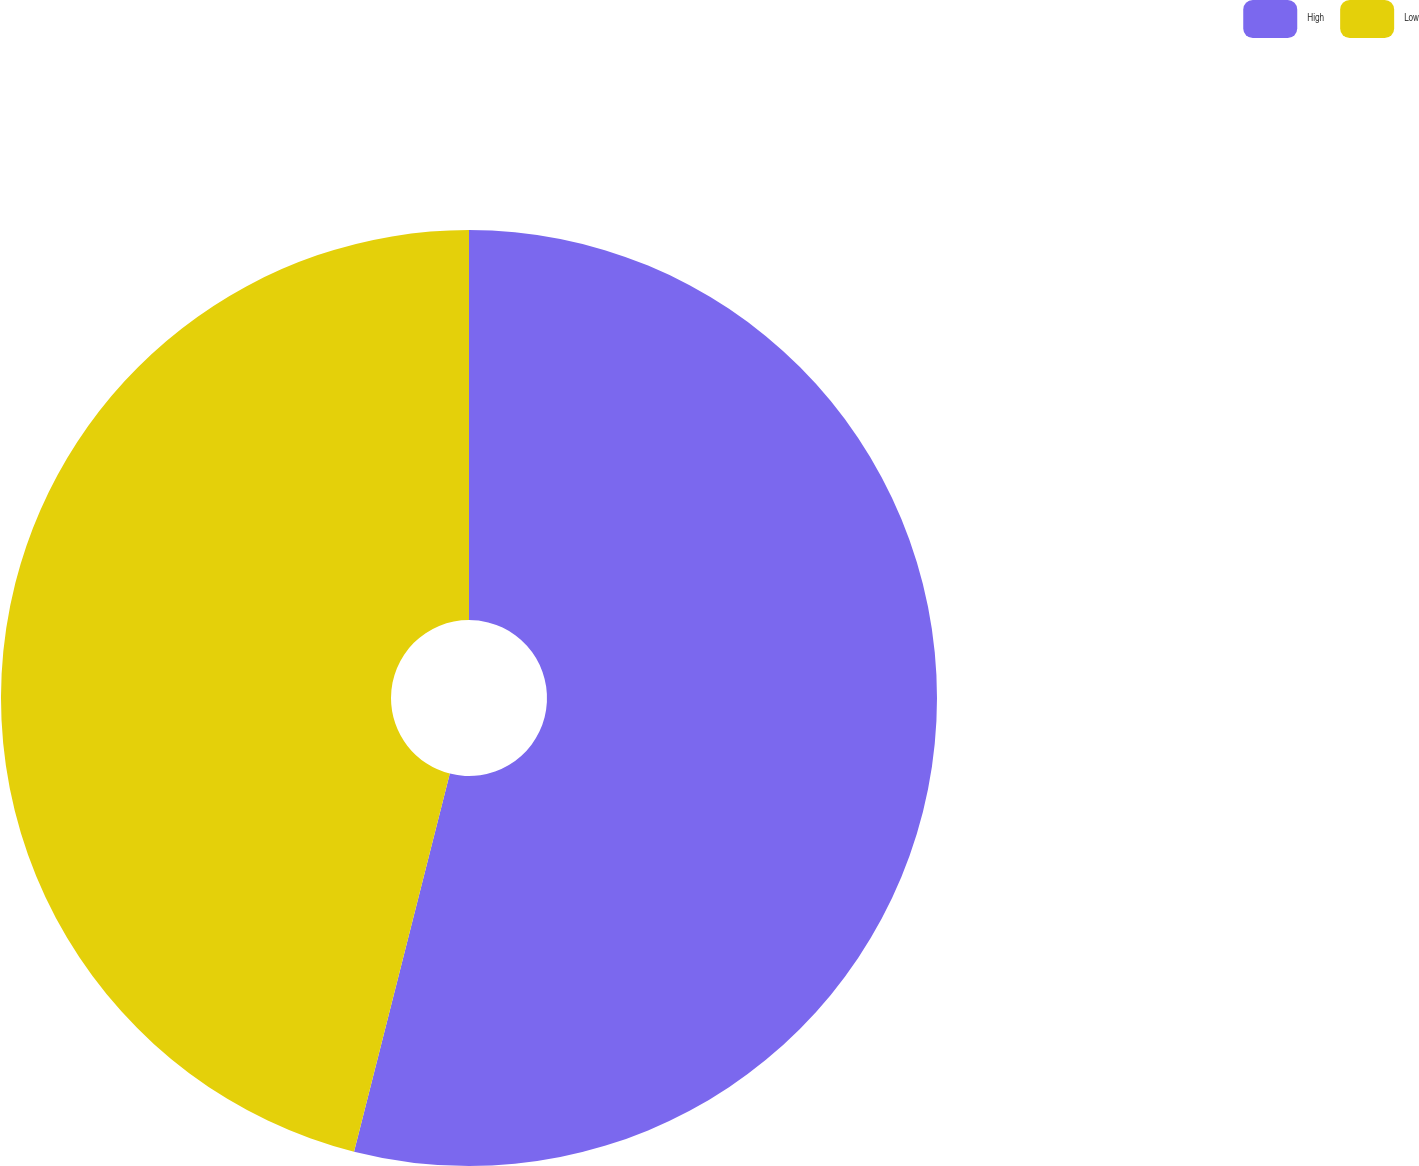<chart> <loc_0><loc_0><loc_500><loc_500><pie_chart><fcel>High<fcel>Low<nl><fcel>53.95%<fcel>46.05%<nl></chart> 